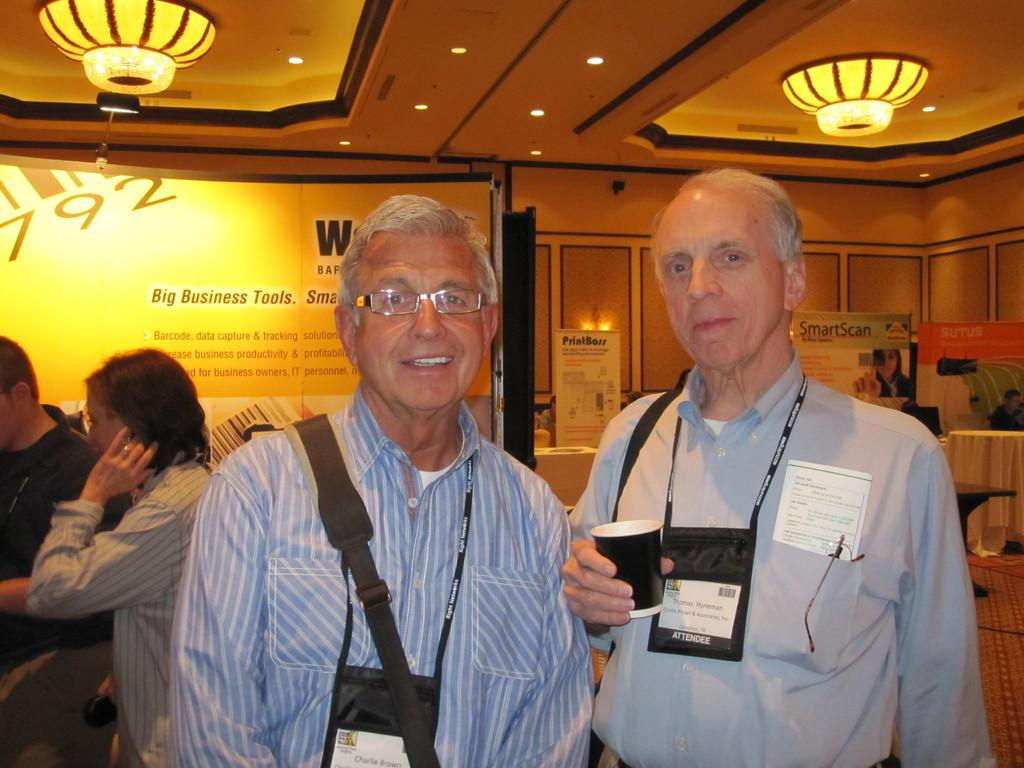How many people are in the image? There are two men in the image. What are the men wearing? The men are wearing shirts. Do the men have any identification in the image? Yes, the men have ID cards. What can be seen at the top of the image? There are ceiling lights visible at the top of the image. What type of eggnog is being served at the volcano in the image? There is no eggnog or volcano present in the image. 